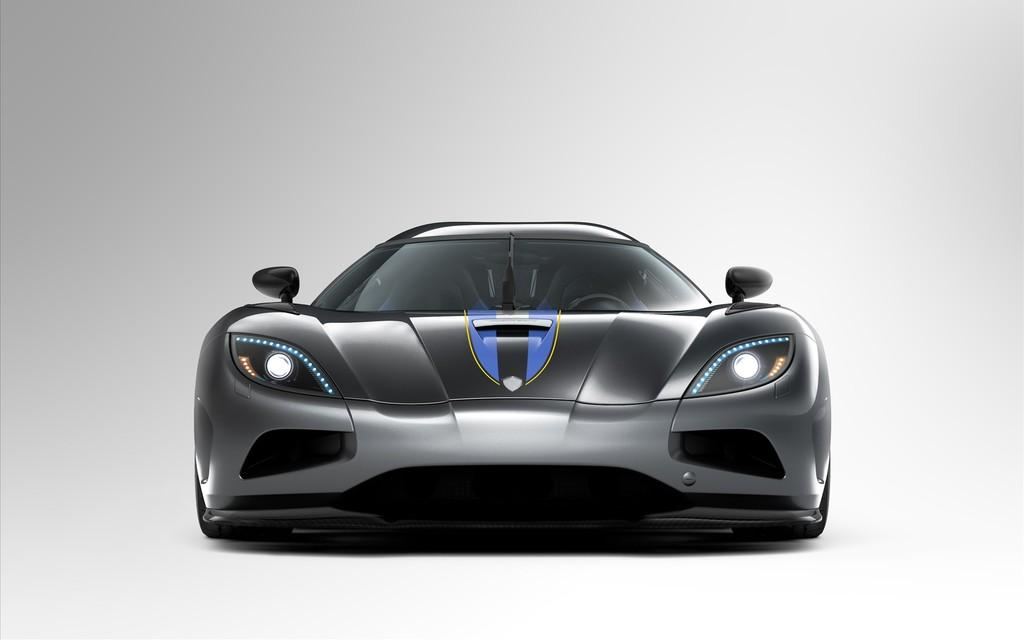What is the main subject in the center of the image? There is a car in the center of the image. What color is the car in the image? The car is grey in color. What type of story is being told by the yak in the image? There is no yak present in the image, so no story is being told. What act is the car performing in the image? The car is not performing any act in the image; it is simply parked or stationary. 